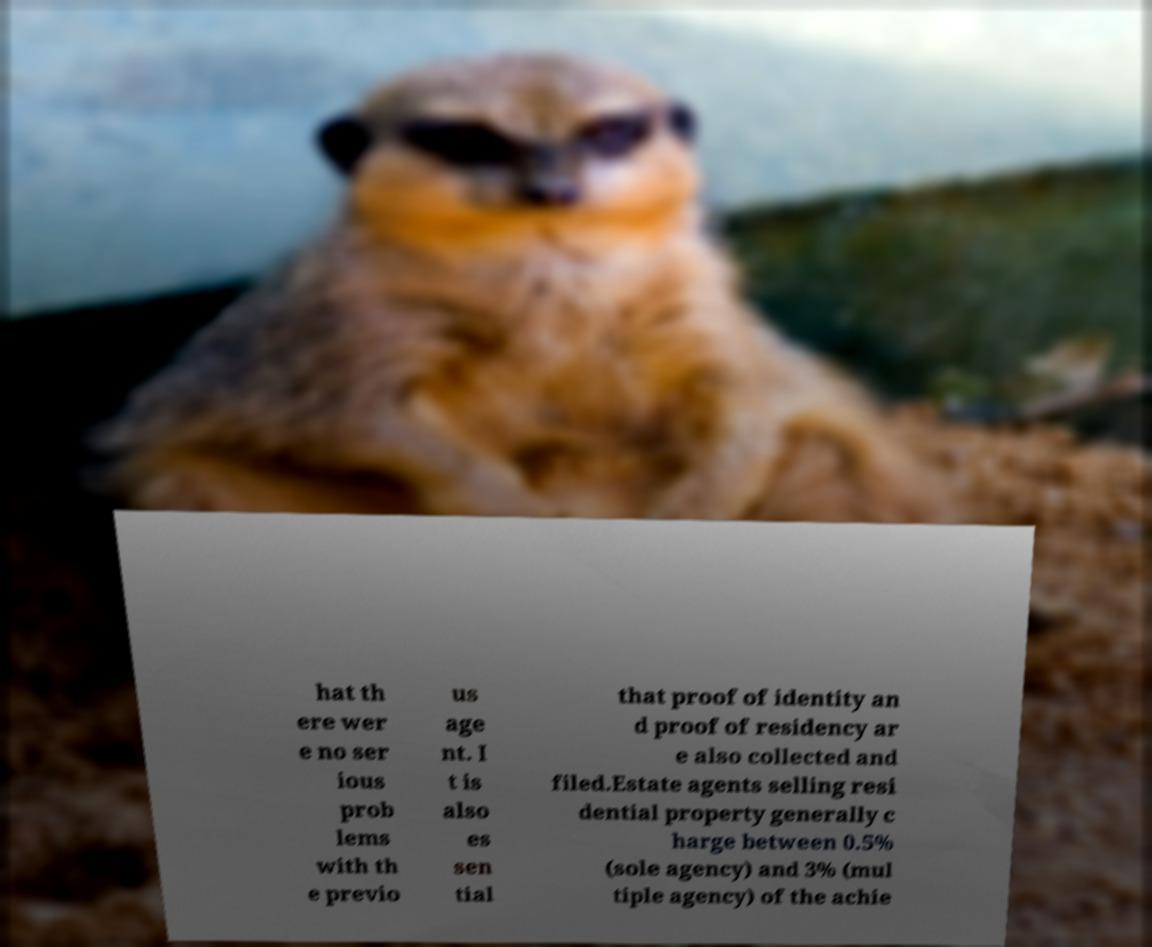Please identify and transcribe the text found in this image. hat th ere wer e no ser ious prob lems with th e previo us age nt. I t is also es sen tial that proof of identity an d proof of residency ar e also collected and filed.Estate agents selling resi dential property generally c harge between 0.5% (sole agency) and 3% (mul tiple agency) of the achie 